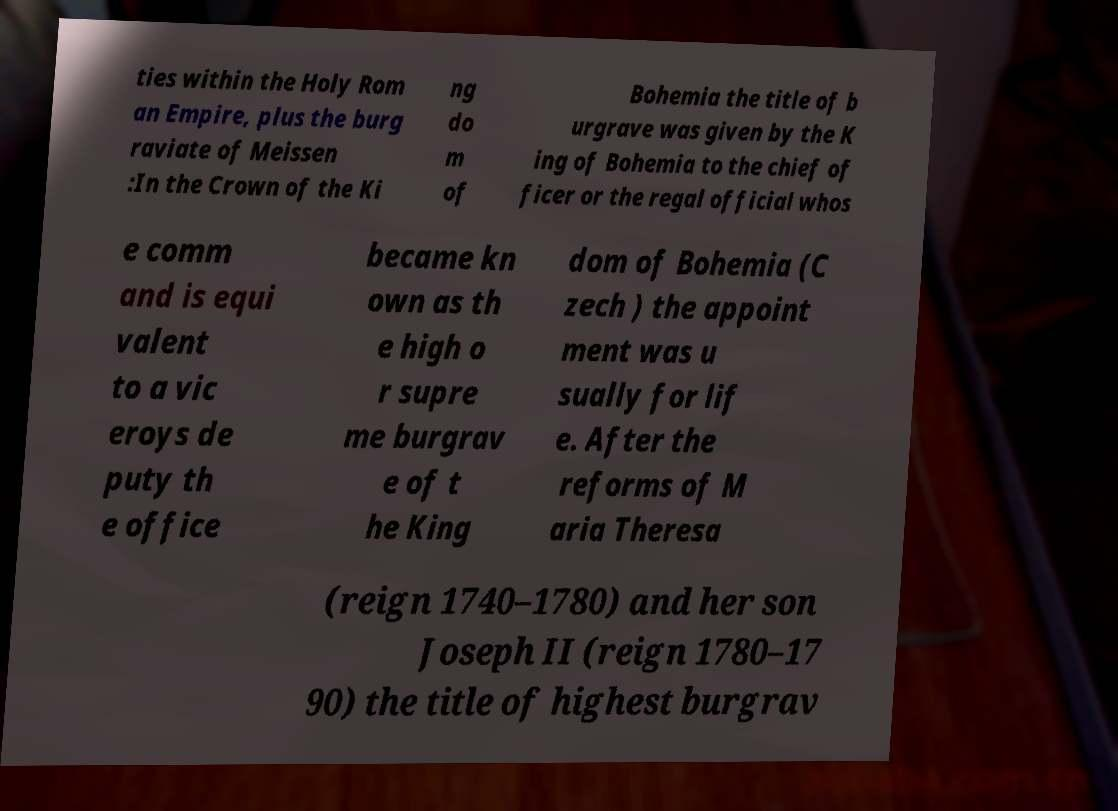Can you accurately transcribe the text from the provided image for me? ties within the Holy Rom an Empire, plus the burg raviate of Meissen :In the Crown of the Ki ng do m of Bohemia the title of b urgrave was given by the K ing of Bohemia to the chief of ficer or the regal official whos e comm and is equi valent to a vic eroys de puty th e office became kn own as th e high o r supre me burgrav e of t he King dom of Bohemia (C zech ) the appoint ment was u sually for lif e. After the reforms of M aria Theresa (reign 1740–1780) and her son Joseph II (reign 1780–17 90) the title of highest burgrav 